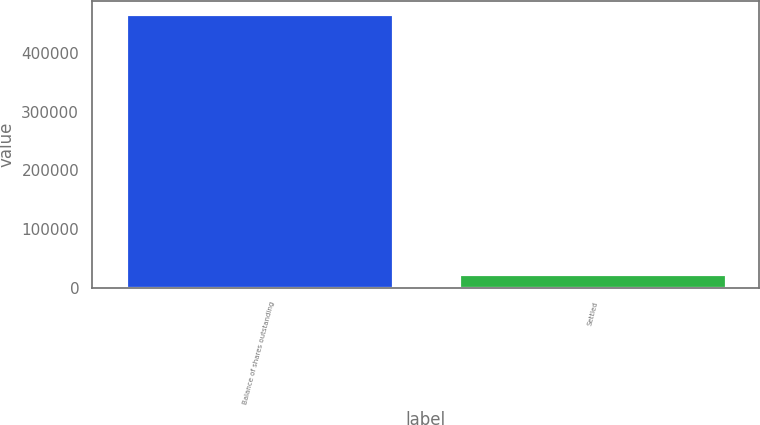Convert chart to OTSL. <chart><loc_0><loc_0><loc_500><loc_500><bar_chart><fcel>Balance of shares outstanding<fcel>Settled<nl><fcel>466387<fcel>23419<nl></chart> 